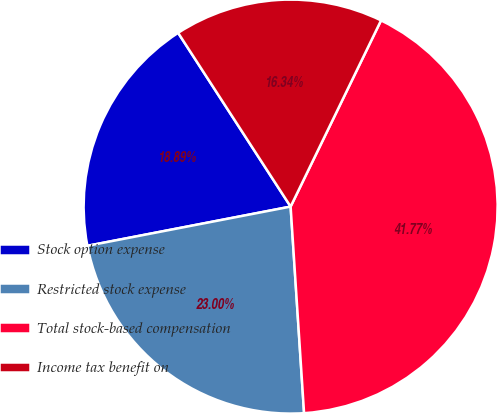Convert chart to OTSL. <chart><loc_0><loc_0><loc_500><loc_500><pie_chart><fcel>Stock option expense<fcel>Restricted stock expense<fcel>Total stock-based compensation<fcel>Income tax benefit on<nl><fcel>18.89%<fcel>23.0%<fcel>41.77%<fcel>16.34%<nl></chart> 